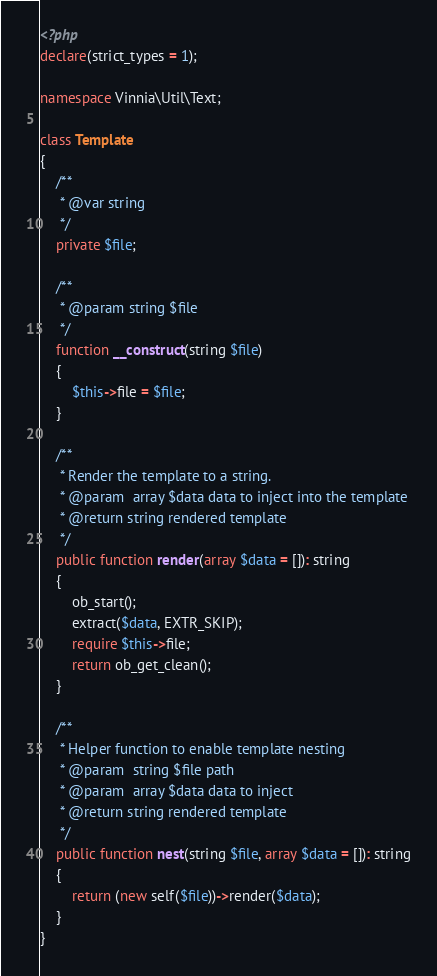<code> <loc_0><loc_0><loc_500><loc_500><_PHP_><?php
declare(strict_types = 1);

namespace Vinnia\Util\Text;

class Template
{
    /**
     * @var string
     */
    private $file;

    /**
     * @param string $file
     */
    function __construct(string $file)
    {
        $this->file = $file;
    }

    /**
     * Render the template to a string.
     * @param  array $data data to inject into the template
     * @return string rendered template
     */
    public function render(array $data = []): string
    {
        ob_start();
        extract($data, EXTR_SKIP);
        require $this->file;
        return ob_get_clean();
    }

    /**
     * Helper function to enable template nesting
     * @param  string $file path
     * @param  array $data data to inject
     * @return string rendered template
     */
    public function nest(string $file, array $data = []): string
    {
        return (new self($file))->render($data);
    }
}
</code> 